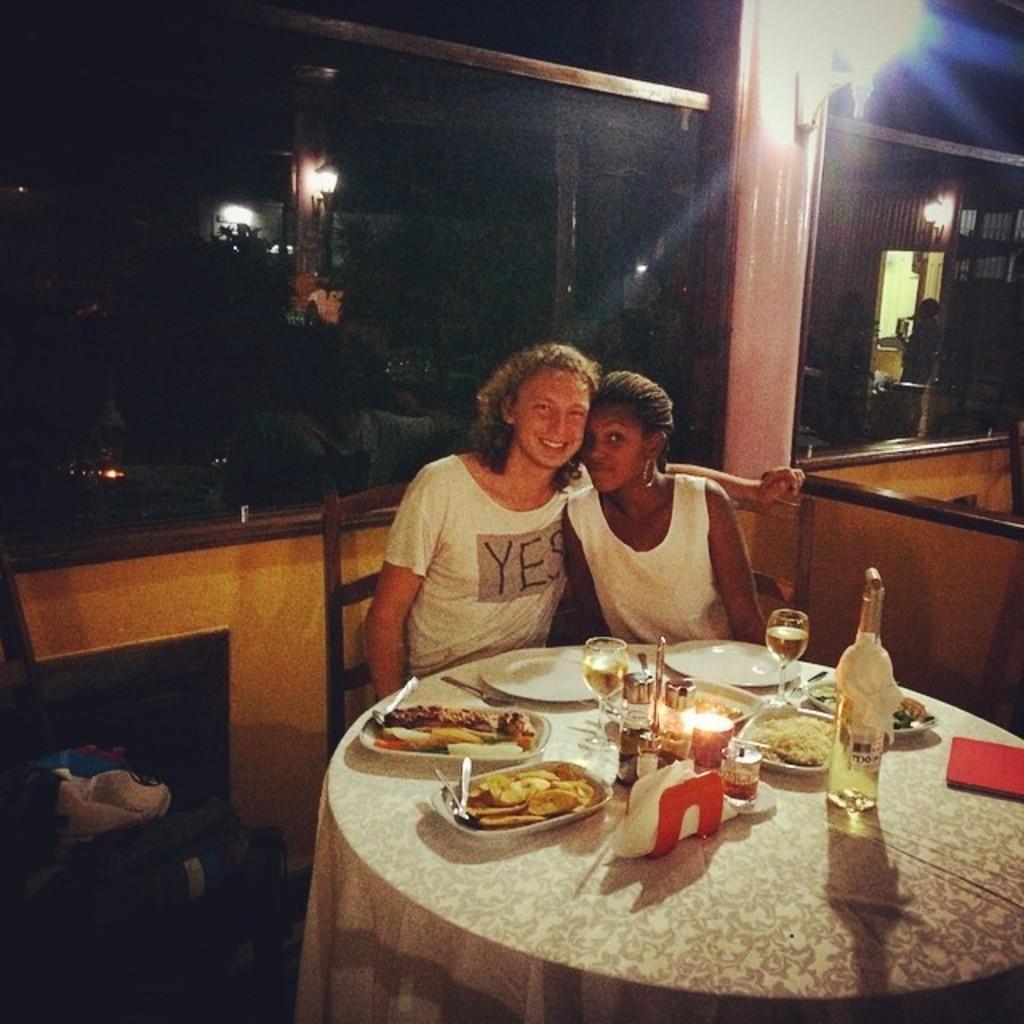Please provide a concise description of this image. In the middle 2 women are sitting on the chairs and there are food items and vodka bottle wine glasses on this table. 